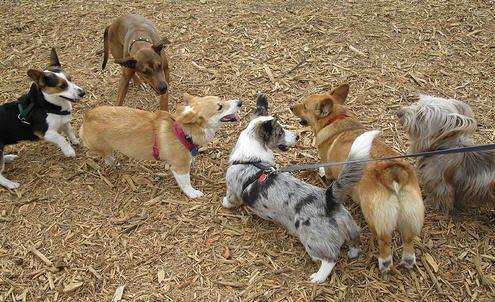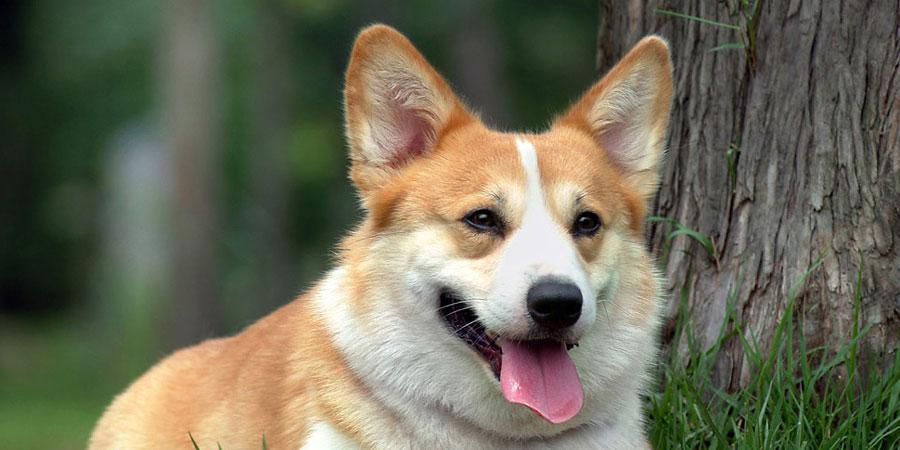The first image is the image on the left, the second image is the image on the right. For the images displayed, is the sentence "An image contains exactly two corgi dogs standing on grass." factually correct? Answer yes or no. No. The first image is the image on the left, the second image is the image on the right. Examine the images to the left and right. Is the description "An image shows a pair of short-legged dogs standing facing forward and posed side-by-side." accurate? Answer yes or no. No. 